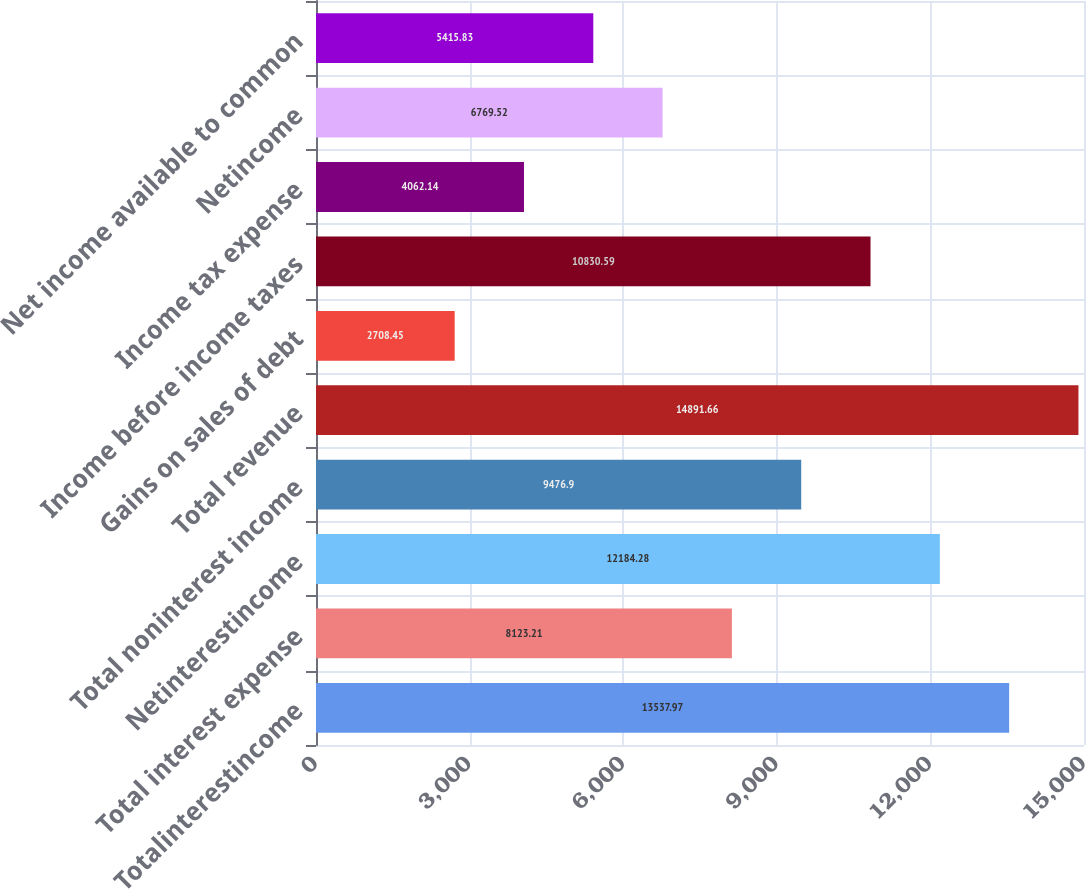Convert chart. <chart><loc_0><loc_0><loc_500><loc_500><bar_chart><fcel>Totalinterestincome<fcel>Total interest expense<fcel>Netinterestincome<fcel>Total noninterest income<fcel>Total revenue<fcel>Gains on sales of debt<fcel>Income before income taxes<fcel>Income tax expense<fcel>Netincome<fcel>Net income available to common<nl><fcel>13538<fcel>8123.21<fcel>12184.3<fcel>9476.9<fcel>14891.7<fcel>2708.45<fcel>10830.6<fcel>4062.14<fcel>6769.52<fcel>5415.83<nl></chart> 